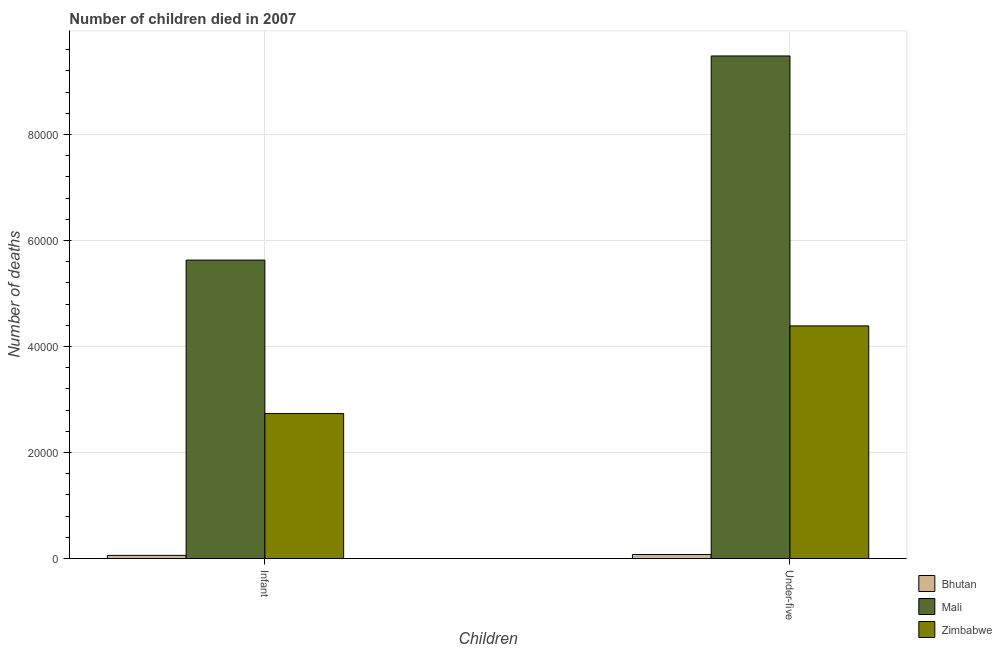How many groups of bars are there?
Keep it short and to the point. 2. Are the number of bars per tick equal to the number of legend labels?
Give a very brief answer. Yes. Are the number of bars on each tick of the X-axis equal?
Provide a succinct answer. Yes. How many bars are there on the 2nd tick from the left?
Your answer should be very brief. 3. What is the label of the 1st group of bars from the left?
Give a very brief answer. Infant. What is the number of infant deaths in Bhutan?
Your response must be concise. 605. Across all countries, what is the maximum number of under-five deaths?
Provide a short and direct response. 9.48e+04. Across all countries, what is the minimum number of infant deaths?
Provide a short and direct response. 605. In which country was the number of under-five deaths maximum?
Provide a short and direct response. Mali. In which country was the number of under-five deaths minimum?
Give a very brief answer. Bhutan. What is the total number of under-five deaths in the graph?
Provide a succinct answer. 1.40e+05. What is the difference between the number of under-five deaths in Mali and that in Bhutan?
Your answer should be very brief. 9.41e+04. What is the difference between the number of infant deaths in Zimbabwe and the number of under-five deaths in Bhutan?
Offer a terse response. 2.66e+04. What is the average number of infant deaths per country?
Your response must be concise. 2.81e+04. What is the difference between the number of infant deaths and number of under-five deaths in Zimbabwe?
Offer a terse response. -1.65e+04. In how many countries, is the number of infant deaths greater than 48000 ?
Provide a succinct answer. 1. What is the ratio of the number of under-five deaths in Mali to that in Zimbabwe?
Give a very brief answer. 2.16. Is the number of under-five deaths in Mali less than that in Bhutan?
Ensure brevity in your answer.  No. In how many countries, is the number of under-five deaths greater than the average number of under-five deaths taken over all countries?
Ensure brevity in your answer.  1. What does the 1st bar from the left in Under-five represents?
Your answer should be very brief. Bhutan. What does the 1st bar from the right in Under-five represents?
Offer a very short reply. Zimbabwe. Are all the bars in the graph horizontal?
Your answer should be very brief. No. How many countries are there in the graph?
Make the answer very short. 3. Are the values on the major ticks of Y-axis written in scientific E-notation?
Your answer should be compact. No. Where does the legend appear in the graph?
Your answer should be very brief. Bottom right. What is the title of the graph?
Keep it short and to the point. Number of children died in 2007. What is the label or title of the X-axis?
Ensure brevity in your answer.  Children. What is the label or title of the Y-axis?
Offer a very short reply. Number of deaths. What is the Number of deaths in Bhutan in Infant?
Ensure brevity in your answer.  605. What is the Number of deaths in Mali in Infant?
Provide a short and direct response. 5.63e+04. What is the Number of deaths of Zimbabwe in Infant?
Ensure brevity in your answer.  2.74e+04. What is the Number of deaths of Bhutan in Under-five?
Provide a succinct answer. 768. What is the Number of deaths in Mali in Under-five?
Make the answer very short. 9.48e+04. What is the Number of deaths of Zimbabwe in Under-five?
Offer a very short reply. 4.39e+04. Across all Children, what is the maximum Number of deaths in Bhutan?
Give a very brief answer. 768. Across all Children, what is the maximum Number of deaths in Mali?
Offer a very short reply. 9.48e+04. Across all Children, what is the maximum Number of deaths of Zimbabwe?
Provide a short and direct response. 4.39e+04. Across all Children, what is the minimum Number of deaths of Bhutan?
Your answer should be very brief. 605. Across all Children, what is the minimum Number of deaths of Mali?
Your answer should be compact. 5.63e+04. Across all Children, what is the minimum Number of deaths of Zimbabwe?
Ensure brevity in your answer.  2.74e+04. What is the total Number of deaths of Bhutan in the graph?
Make the answer very short. 1373. What is the total Number of deaths in Mali in the graph?
Give a very brief answer. 1.51e+05. What is the total Number of deaths of Zimbabwe in the graph?
Give a very brief answer. 7.13e+04. What is the difference between the Number of deaths of Bhutan in Infant and that in Under-five?
Make the answer very short. -163. What is the difference between the Number of deaths in Mali in Infant and that in Under-five?
Keep it short and to the point. -3.85e+04. What is the difference between the Number of deaths in Zimbabwe in Infant and that in Under-five?
Keep it short and to the point. -1.65e+04. What is the difference between the Number of deaths of Bhutan in Infant and the Number of deaths of Mali in Under-five?
Your answer should be very brief. -9.42e+04. What is the difference between the Number of deaths in Bhutan in Infant and the Number of deaths in Zimbabwe in Under-five?
Ensure brevity in your answer.  -4.33e+04. What is the difference between the Number of deaths of Mali in Infant and the Number of deaths of Zimbabwe in Under-five?
Keep it short and to the point. 1.24e+04. What is the average Number of deaths of Bhutan per Children?
Give a very brief answer. 686.5. What is the average Number of deaths of Mali per Children?
Provide a succinct answer. 7.56e+04. What is the average Number of deaths of Zimbabwe per Children?
Give a very brief answer. 3.56e+04. What is the difference between the Number of deaths in Bhutan and Number of deaths in Mali in Infant?
Keep it short and to the point. -5.57e+04. What is the difference between the Number of deaths of Bhutan and Number of deaths of Zimbabwe in Infant?
Give a very brief answer. -2.68e+04. What is the difference between the Number of deaths in Mali and Number of deaths in Zimbabwe in Infant?
Offer a terse response. 2.90e+04. What is the difference between the Number of deaths of Bhutan and Number of deaths of Mali in Under-five?
Provide a short and direct response. -9.41e+04. What is the difference between the Number of deaths of Bhutan and Number of deaths of Zimbabwe in Under-five?
Make the answer very short. -4.31e+04. What is the difference between the Number of deaths in Mali and Number of deaths in Zimbabwe in Under-five?
Provide a short and direct response. 5.09e+04. What is the ratio of the Number of deaths in Bhutan in Infant to that in Under-five?
Offer a terse response. 0.79. What is the ratio of the Number of deaths of Mali in Infant to that in Under-five?
Provide a short and direct response. 0.59. What is the ratio of the Number of deaths of Zimbabwe in Infant to that in Under-five?
Provide a short and direct response. 0.62. What is the difference between the highest and the second highest Number of deaths in Bhutan?
Provide a short and direct response. 163. What is the difference between the highest and the second highest Number of deaths of Mali?
Provide a short and direct response. 3.85e+04. What is the difference between the highest and the second highest Number of deaths in Zimbabwe?
Provide a short and direct response. 1.65e+04. What is the difference between the highest and the lowest Number of deaths of Bhutan?
Provide a succinct answer. 163. What is the difference between the highest and the lowest Number of deaths in Mali?
Ensure brevity in your answer.  3.85e+04. What is the difference between the highest and the lowest Number of deaths in Zimbabwe?
Provide a succinct answer. 1.65e+04. 